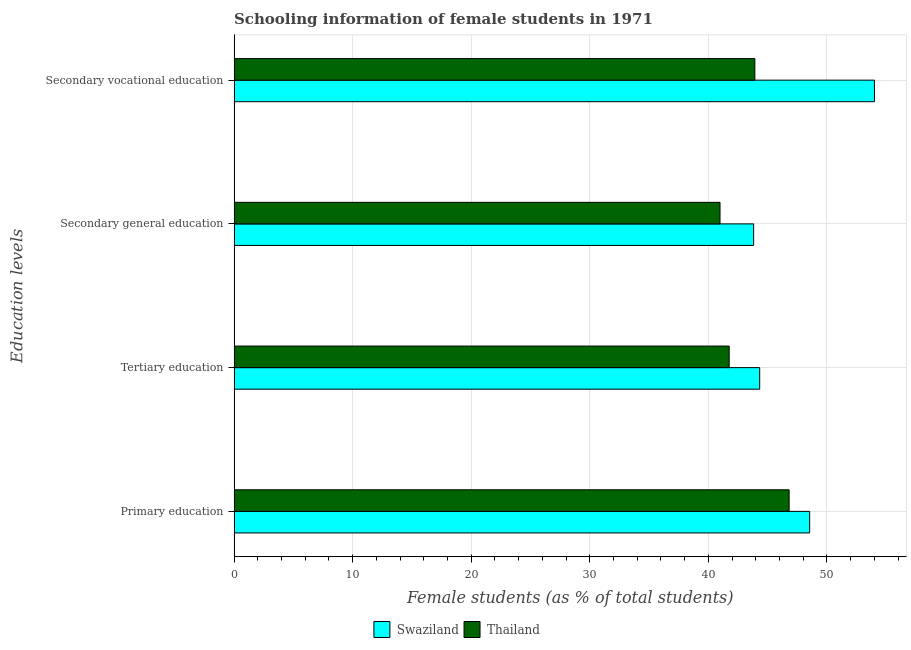How many different coloured bars are there?
Your response must be concise. 2. How many groups of bars are there?
Keep it short and to the point. 4. Are the number of bars per tick equal to the number of legend labels?
Offer a terse response. Yes. What is the label of the 4th group of bars from the top?
Your answer should be very brief. Primary education. What is the percentage of female students in tertiary education in Swaziland?
Make the answer very short. 44.33. Across all countries, what is the maximum percentage of female students in primary education?
Ensure brevity in your answer.  48.54. Across all countries, what is the minimum percentage of female students in secondary vocational education?
Offer a very short reply. 43.92. In which country was the percentage of female students in secondary vocational education maximum?
Your answer should be very brief. Swaziland. In which country was the percentage of female students in secondary vocational education minimum?
Offer a terse response. Thailand. What is the total percentage of female students in secondary education in the graph?
Your answer should be very brief. 84.8. What is the difference between the percentage of female students in primary education in Swaziland and that in Thailand?
Make the answer very short. 1.73. What is the difference between the percentage of female students in primary education in Thailand and the percentage of female students in tertiary education in Swaziland?
Your answer should be very brief. 2.48. What is the average percentage of female students in tertiary education per country?
Your answer should be very brief. 43.04. What is the difference between the percentage of female students in tertiary education and percentage of female students in primary education in Thailand?
Provide a short and direct response. -5.05. In how many countries, is the percentage of female students in tertiary education greater than 44 %?
Offer a terse response. 1. What is the ratio of the percentage of female students in secondary vocational education in Swaziland to that in Thailand?
Give a very brief answer. 1.23. What is the difference between the highest and the second highest percentage of female students in secondary vocational education?
Give a very brief answer. 10.09. What is the difference between the highest and the lowest percentage of female students in primary education?
Ensure brevity in your answer.  1.73. In how many countries, is the percentage of female students in tertiary education greater than the average percentage of female students in tertiary education taken over all countries?
Your answer should be compact. 1. What does the 1st bar from the top in Secondary vocational education represents?
Offer a terse response. Thailand. What does the 2nd bar from the bottom in Secondary vocational education represents?
Your answer should be very brief. Thailand. Is it the case that in every country, the sum of the percentage of female students in primary education and percentage of female students in tertiary education is greater than the percentage of female students in secondary education?
Provide a short and direct response. Yes. How many bars are there?
Make the answer very short. 8. What is the difference between two consecutive major ticks on the X-axis?
Your answer should be compact. 10. Are the values on the major ticks of X-axis written in scientific E-notation?
Offer a terse response. No. Does the graph contain any zero values?
Keep it short and to the point. No. Does the graph contain grids?
Offer a very short reply. Yes. What is the title of the graph?
Keep it short and to the point. Schooling information of female students in 1971. Does "Canada" appear as one of the legend labels in the graph?
Your answer should be compact. No. What is the label or title of the X-axis?
Give a very brief answer. Female students (as % of total students). What is the label or title of the Y-axis?
Give a very brief answer. Education levels. What is the Female students (as % of total students) of Swaziland in Primary education?
Offer a terse response. 48.54. What is the Female students (as % of total students) of Thailand in Primary education?
Offer a terse response. 46.81. What is the Female students (as % of total students) of Swaziland in Tertiary education?
Make the answer very short. 44.33. What is the Female students (as % of total students) in Thailand in Tertiary education?
Provide a short and direct response. 41.76. What is the Female students (as % of total students) in Swaziland in Secondary general education?
Your answer should be very brief. 43.82. What is the Female students (as % of total students) of Thailand in Secondary general education?
Provide a succinct answer. 40.98. What is the Female students (as % of total students) in Swaziland in Secondary vocational education?
Your answer should be compact. 54.01. What is the Female students (as % of total students) of Thailand in Secondary vocational education?
Give a very brief answer. 43.92. Across all Education levels, what is the maximum Female students (as % of total students) of Swaziland?
Offer a terse response. 54.01. Across all Education levels, what is the maximum Female students (as % of total students) of Thailand?
Keep it short and to the point. 46.81. Across all Education levels, what is the minimum Female students (as % of total students) in Swaziland?
Give a very brief answer. 43.82. Across all Education levels, what is the minimum Female students (as % of total students) of Thailand?
Offer a very short reply. 40.98. What is the total Female students (as % of total students) in Swaziland in the graph?
Provide a short and direct response. 190.69. What is the total Female students (as % of total students) of Thailand in the graph?
Provide a succinct answer. 173.46. What is the difference between the Female students (as % of total students) of Swaziland in Primary education and that in Tertiary education?
Provide a short and direct response. 4.21. What is the difference between the Female students (as % of total students) of Thailand in Primary education and that in Tertiary education?
Offer a very short reply. 5.05. What is the difference between the Female students (as % of total students) in Swaziland in Primary education and that in Secondary general education?
Your answer should be very brief. 4.72. What is the difference between the Female students (as % of total students) of Thailand in Primary education and that in Secondary general education?
Keep it short and to the point. 5.83. What is the difference between the Female students (as % of total students) of Swaziland in Primary education and that in Secondary vocational education?
Provide a succinct answer. -5.47. What is the difference between the Female students (as % of total students) in Thailand in Primary education and that in Secondary vocational education?
Provide a succinct answer. 2.89. What is the difference between the Female students (as % of total students) of Swaziland in Tertiary education and that in Secondary general education?
Your response must be concise. 0.51. What is the difference between the Female students (as % of total students) in Thailand in Tertiary education and that in Secondary general education?
Offer a very short reply. 0.77. What is the difference between the Female students (as % of total students) of Swaziland in Tertiary education and that in Secondary vocational education?
Provide a succinct answer. -9.68. What is the difference between the Female students (as % of total students) in Thailand in Tertiary education and that in Secondary vocational education?
Make the answer very short. -2.16. What is the difference between the Female students (as % of total students) in Swaziland in Secondary general education and that in Secondary vocational education?
Make the answer very short. -10.19. What is the difference between the Female students (as % of total students) in Thailand in Secondary general education and that in Secondary vocational education?
Make the answer very short. -2.94. What is the difference between the Female students (as % of total students) in Swaziland in Primary education and the Female students (as % of total students) in Thailand in Tertiary education?
Make the answer very short. 6.79. What is the difference between the Female students (as % of total students) of Swaziland in Primary education and the Female students (as % of total students) of Thailand in Secondary general education?
Keep it short and to the point. 7.56. What is the difference between the Female students (as % of total students) of Swaziland in Primary education and the Female students (as % of total students) of Thailand in Secondary vocational education?
Provide a short and direct response. 4.62. What is the difference between the Female students (as % of total students) of Swaziland in Tertiary education and the Female students (as % of total students) of Thailand in Secondary general education?
Your answer should be compact. 3.35. What is the difference between the Female students (as % of total students) of Swaziland in Tertiary education and the Female students (as % of total students) of Thailand in Secondary vocational education?
Your answer should be very brief. 0.41. What is the difference between the Female students (as % of total students) in Swaziland in Secondary general education and the Female students (as % of total students) in Thailand in Secondary vocational education?
Offer a very short reply. -0.1. What is the average Female students (as % of total students) of Swaziland per Education levels?
Offer a terse response. 47.67. What is the average Female students (as % of total students) of Thailand per Education levels?
Your answer should be very brief. 43.37. What is the difference between the Female students (as % of total students) of Swaziland and Female students (as % of total students) of Thailand in Primary education?
Give a very brief answer. 1.73. What is the difference between the Female students (as % of total students) of Swaziland and Female students (as % of total students) of Thailand in Tertiary education?
Provide a succinct answer. 2.57. What is the difference between the Female students (as % of total students) of Swaziland and Female students (as % of total students) of Thailand in Secondary general education?
Your response must be concise. 2.84. What is the difference between the Female students (as % of total students) of Swaziland and Female students (as % of total students) of Thailand in Secondary vocational education?
Provide a succinct answer. 10.09. What is the ratio of the Female students (as % of total students) of Swaziland in Primary education to that in Tertiary education?
Give a very brief answer. 1.1. What is the ratio of the Female students (as % of total students) of Thailand in Primary education to that in Tertiary education?
Make the answer very short. 1.12. What is the ratio of the Female students (as % of total students) of Swaziland in Primary education to that in Secondary general education?
Provide a succinct answer. 1.11. What is the ratio of the Female students (as % of total students) of Thailand in Primary education to that in Secondary general education?
Give a very brief answer. 1.14. What is the ratio of the Female students (as % of total students) in Swaziland in Primary education to that in Secondary vocational education?
Your response must be concise. 0.9. What is the ratio of the Female students (as % of total students) in Thailand in Primary education to that in Secondary vocational education?
Make the answer very short. 1.07. What is the ratio of the Female students (as % of total students) in Swaziland in Tertiary education to that in Secondary general education?
Provide a succinct answer. 1.01. What is the ratio of the Female students (as % of total students) in Thailand in Tertiary education to that in Secondary general education?
Your answer should be compact. 1.02. What is the ratio of the Female students (as % of total students) of Swaziland in Tertiary education to that in Secondary vocational education?
Ensure brevity in your answer.  0.82. What is the ratio of the Female students (as % of total students) in Thailand in Tertiary education to that in Secondary vocational education?
Your response must be concise. 0.95. What is the ratio of the Female students (as % of total students) of Swaziland in Secondary general education to that in Secondary vocational education?
Offer a terse response. 0.81. What is the ratio of the Female students (as % of total students) in Thailand in Secondary general education to that in Secondary vocational education?
Give a very brief answer. 0.93. What is the difference between the highest and the second highest Female students (as % of total students) of Swaziland?
Give a very brief answer. 5.47. What is the difference between the highest and the second highest Female students (as % of total students) in Thailand?
Your answer should be compact. 2.89. What is the difference between the highest and the lowest Female students (as % of total students) in Swaziland?
Your answer should be very brief. 10.19. What is the difference between the highest and the lowest Female students (as % of total students) of Thailand?
Provide a succinct answer. 5.83. 